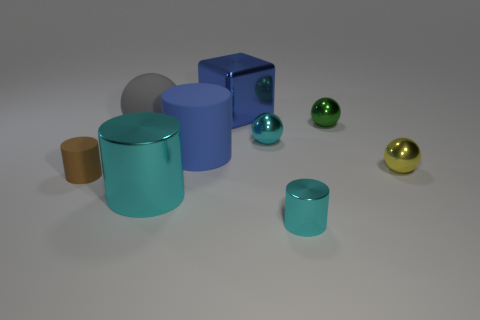What number of cylinders are the same color as the large metal cube?
Give a very brief answer. 1. What size is the cyan cylinder that is in front of the cyan cylinder behind the small cyan shiny thing that is in front of the small cyan metallic sphere?
Keep it short and to the point. Small. What number of shiny objects are cubes or spheres?
Provide a succinct answer. 4. Do the small green metal thing and the tiny shiny thing right of the tiny green metal sphere have the same shape?
Offer a very short reply. Yes. Is the number of big blue things right of the gray rubber object greater than the number of green shiny objects on the right side of the green metallic sphere?
Offer a very short reply. Yes. Are there any other things that are the same color as the big metallic cylinder?
Make the answer very short. Yes. There is a small cylinder that is left of the cyan cylinder to the right of the blue cube; is there a tiny cyan metallic thing in front of it?
Give a very brief answer. Yes. There is a tiny metallic object that is on the right side of the tiny green sphere; is it the same shape as the large gray matte object?
Keep it short and to the point. Yes. Is the number of large rubber cylinders that are on the left side of the matte sphere less than the number of cyan metal things behind the big cyan cylinder?
Make the answer very short. Yes. What is the gray sphere made of?
Ensure brevity in your answer.  Rubber. 